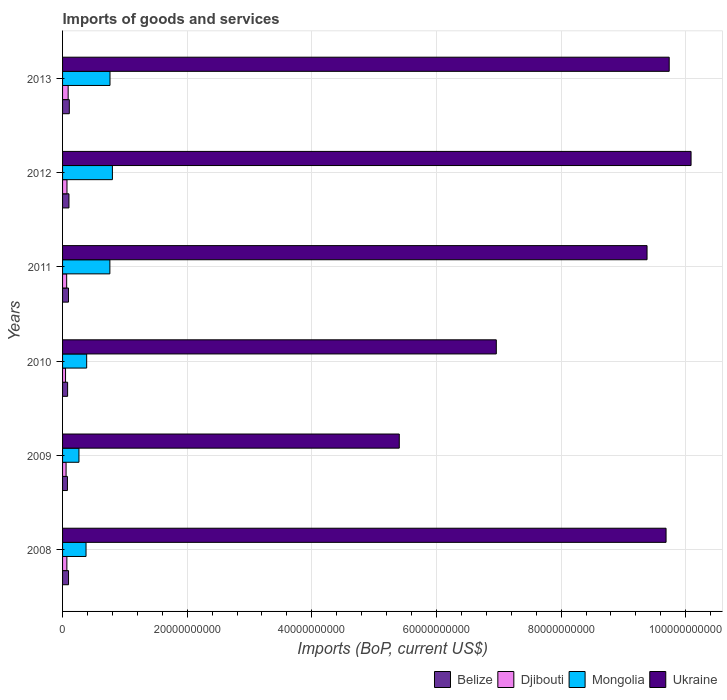How many different coloured bars are there?
Give a very brief answer. 4. Are the number of bars on each tick of the Y-axis equal?
Give a very brief answer. Yes. How many bars are there on the 1st tick from the bottom?
Your answer should be very brief. 4. What is the amount spent on imports in Mongolia in 2008?
Make the answer very short. 3.77e+09. Across all years, what is the maximum amount spent on imports in Ukraine?
Provide a succinct answer. 1.01e+11. Across all years, what is the minimum amount spent on imports in Ukraine?
Your response must be concise. 5.40e+1. What is the total amount spent on imports in Mongolia in the graph?
Keep it short and to the point. 3.35e+1. What is the difference between the amount spent on imports in Ukraine in 2011 and that in 2012?
Offer a very short reply. -7.06e+09. What is the difference between the amount spent on imports in Ukraine in 2011 and the amount spent on imports in Djibouti in 2012?
Offer a terse response. 9.31e+1. What is the average amount spent on imports in Ukraine per year?
Make the answer very short. 8.54e+1. In the year 2013, what is the difference between the amount spent on imports in Djibouti and amount spent on imports in Mongolia?
Give a very brief answer. -6.72e+09. In how many years, is the amount spent on imports in Ukraine greater than 16000000000 US$?
Provide a short and direct response. 6. What is the ratio of the amount spent on imports in Ukraine in 2012 to that in 2013?
Your answer should be compact. 1.04. Is the amount spent on imports in Belize in 2010 less than that in 2011?
Give a very brief answer. Yes. Is the difference between the amount spent on imports in Djibouti in 2008 and 2011 greater than the difference between the amount spent on imports in Mongolia in 2008 and 2011?
Your answer should be very brief. Yes. What is the difference between the highest and the second highest amount spent on imports in Mongolia?
Provide a succinct answer. 3.85e+08. What is the difference between the highest and the lowest amount spent on imports in Belize?
Provide a succinct answer. 3.01e+08. In how many years, is the amount spent on imports in Belize greater than the average amount spent on imports in Belize taken over all years?
Provide a succinct answer. 4. Is the sum of the amount spent on imports in Djibouti in 2009 and 2011 greater than the maximum amount spent on imports in Belize across all years?
Offer a very short reply. Yes. What does the 2nd bar from the top in 2013 represents?
Provide a succinct answer. Mongolia. What does the 2nd bar from the bottom in 2012 represents?
Your answer should be compact. Djibouti. How many bars are there?
Your answer should be very brief. 24. Are the values on the major ticks of X-axis written in scientific E-notation?
Your answer should be very brief. No. How many legend labels are there?
Your answer should be very brief. 4. How are the legend labels stacked?
Your answer should be very brief. Horizontal. What is the title of the graph?
Ensure brevity in your answer.  Imports of goods and services. Does "New Caledonia" appear as one of the legend labels in the graph?
Keep it short and to the point. No. What is the label or title of the X-axis?
Provide a short and direct response. Imports (BoP, current US$). What is the Imports (BoP, current US$) of Belize in 2008?
Ensure brevity in your answer.  9.58e+08. What is the Imports (BoP, current US$) of Djibouti in 2008?
Offer a terse response. 6.91e+08. What is the Imports (BoP, current US$) of Mongolia in 2008?
Make the answer very short. 3.77e+09. What is the Imports (BoP, current US$) in Ukraine in 2008?
Offer a terse response. 9.68e+1. What is the Imports (BoP, current US$) of Belize in 2009?
Your response must be concise. 7.82e+08. What is the Imports (BoP, current US$) in Djibouti in 2009?
Ensure brevity in your answer.  5.65e+08. What is the Imports (BoP, current US$) in Mongolia in 2009?
Your answer should be very brief. 2.63e+09. What is the Imports (BoP, current US$) in Ukraine in 2009?
Your answer should be compact. 5.40e+1. What is the Imports (BoP, current US$) of Belize in 2010?
Your answer should be compact. 8.10e+08. What is the Imports (BoP, current US$) in Djibouti in 2010?
Provide a succinct answer. 4.78e+08. What is the Imports (BoP, current US$) in Mongolia in 2010?
Keep it short and to the point. 3.87e+09. What is the Imports (BoP, current US$) in Ukraine in 2010?
Give a very brief answer. 6.96e+1. What is the Imports (BoP, current US$) in Belize in 2011?
Make the answer very short. 9.49e+08. What is the Imports (BoP, current US$) in Djibouti in 2011?
Provide a succinct answer. 6.58e+08. What is the Imports (BoP, current US$) of Mongolia in 2011?
Your answer should be very brief. 7.59e+09. What is the Imports (BoP, current US$) in Ukraine in 2011?
Your answer should be compact. 9.38e+1. What is the Imports (BoP, current US$) of Belize in 2012?
Provide a succinct answer. 1.03e+09. What is the Imports (BoP, current US$) of Djibouti in 2012?
Your answer should be compact. 7.09e+08. What is the Imports (BoP, current US$) in Mongolia in 2012?
Offer a very short reply. 8.00e+09. What is the Imports (BoP, current US$) of Ukraine in 2012?
Offer a terse response. 1.01e+11. What is the Imports (BoP, current US$) in Belize in 2013?
Your answer should be compact. 1.08e+09. What is the Imports (BoP, current US$) in Djibouti in 2013?
Provide a short and direct response. 8.98e+08. What is the Imports (BoP, current US$) in Mongolia in 2013?
Ensure brevity in your answer.  7.61e+09. What is the Imports (BoP, current US$) of Ukraine in 2013?
Offer a terse response. 9.74e+1. Across all years, what is the maximum Imports (BoP, current US$) in Belize?
Your answer should be compact. 1.08e+09. Across all years, what is the maximum Imports (BoP, current US$) in Djibouti?
Ensure brevity in your answer.  8.98e+08. Across all years, what is the maximum Imports (BoP, current US$) in Mongolia?
Offer a terse response. 8.00e+09. Across all years, what is the maximum Imports (BoP, current US$) of Ukraine?
Provide a succinct answer. 1.01e+11. Across all years, what is the minimum Imports (BoP, current US$) of Belize?
Provide a short and direct response. 7.82e+08. Across all years, what is the minimum Imports (BoP, current US$) in Djibouti?
Offer a very short reply. 4.78e+08. Across all years, what is the minimum Imports (BoP, current US$) in Mongolia?
Ensure brevity in your answer.  2.63e+09. Across all years, what is the minimum Imports (BoP, current US$) of Ukraine?
Give a very brief answer. 5.40e+1. What is the total Imports (BoP, current US$) in Belize in the graph?
Your answer should be compact. 5.61e+09. What is the total Imports (BoP, current US$) in Djibouti in the graph?
Provide a short and direct response. 4.00e+09. What is the total Imports (BoP, current US$) in Mongolia in the graph?
Ensure brevity in your answer.  3.35e+1. What is the total Imports (BoP, current US$) of Ukraine in the graph?
Offer a very short reply. 5.13e+11. What is the difference between the Imports (BoP, current US$) in Belize in 2008 and that in 2009?
Ensure brevity in your answer.  1.76e+08. What is the difference between the Imports (BoP, current US$) of Djibouti in 2008 and that in 2009?
Give a very brief answer. 1.26e+08. What is the difference between the Imports (BoP, current US$) in Mongolia in 2008 and that in 2009?
Provide a succinct answer. 1.14e+09. What is the difference between the Imports (BoP, current US$) in Ukraine in 2008 and that in 2009?
Offer a terse response. 4.28e+1. What is the difference between the Imports (BoP, current US$) of Belize in 2008 and that in 2010?
Keep it short and to the point. 1.48e+08. What is the difference between the Imports (BoP, current US$) of Djibouti in 2008 and that in 2010?
Offer a terse response. 2.12e+08. What is the difference between the Imports (BoP, current US$) of Mongolia in 2008 and that in 2010?
Offer a very short reply. -1.02e+08. What is the difference between the Imports (BoP, current US$) of Ukraine in 2008 and that in 2010?
Your answer should be compact. 2.72e+1. What is the difference between the Imports (BoP, current US$) of Belize in 2008 and that in 2011?
Keep it short and to the point. 8.56e+06. What is the difference between the Imports (BoP, current US$) in Djibouti in 2008 and that in 2011?
Your answer should be compact. 3.23e+07. What is the difference between the Imports (BoP, current US$) of Mongolia in 2008 and that in 2011?
Your answer should be compact. -3.82e+09. What is the difference between the Imports (BoP, current US$) in Ukraine in 2008 and that in 2011?
Your answer should be compact. 3.05e+09. What is the difference between the Imports (BoP, current US$) of Belize in 2008 and that in 2012?
Make the answer very short. -6.72e+07. What is the difference between the Imports (BoP, current US$) of Djibouti in 2008 and that in 2012?
Your answer should be compact. -1.84e+07. What is the difference between the Imports (BoP, current US$) of Mongolia in 2008 and that in 2012?
Your answer should be very brief. -4.23e+09. What is the difference between the Imports (BoP, current US$) in Ukraine in 2008 and that in 2012?
Your answer should be compact. -4.01e+09. What is the difference between the Imports (BoP, current US$) in Belize in 2008 and that in 2013?
Your answer should be compact. -1.26e+08. What is the difference between the Imports (BoP, current US$) of Djibouti in 2008 and that in 2013?
Give a very brief answer. -2.07e+08. What is the difference between the Imports (BoP, current US$) in Mongolia in 2008 and that in 2013?
Offer a very short reply. -3.85e+09. What is the difference between the Imports (BoP, current US$) in Ukraine in 2008 and that in 2013?
Offer a very short reply. -5.05e+08. What is the difference between the Imports (BoP, current US$) in Belize in 2009 and that in 2010?
Make the answer very short. -2.74e+07. What is the difference between the Imports (BoP, current US$) of Djibouti in 2009 and that in 2010?
Offer a very short reply. 8.62e+07. What is the difference between the Imports (BoP, current US$) of Mongolia in 2009 and that in 2010?
Keep it short and to the point. -1.24e+09. What is the difference between the Imports (BoP, current US$) of Ukraine in 2009 and that in 2010?
Keep it short and to the point. -1.56e+1. What is the difference between the Imports (BoP, current US$) of Belize in 2009 and that in 2011?
Ensure brevity in your answer.  -1.67e+08. What is the difference between the Imports (BoP, current US$) in Djibouti in 2009 and that in 2011?
Give a very brief answer. -9.37e+07. What is the difference between the Imports (BoP, current US$) in Mongolia in 2009 and that in 2011?
Offer a very short reply. -4.96e+09. What is the difference between the Imports (BoP, current US$) of Ukraine in 2009 and that in 2011?
Make the answer very short. -3.98e+1. What is the difference between the Imports (BoP, current US$) of Belize in 2009 and that in 2012?
Provide a succinct answer. -2.43e+08. What is the difference between the Imports (BoP, current US$) of Djibouti in 2009 and that in 2012?
Your response must be concise. -1.44e+08. What is the difference between the Imports (BoP, current US$) in Mongolia in 2009 and that in 2012?
Offer a very short reply. -5.37e+09. What is the difference between the Imports (BoP, current US$) of Ukraine in 2009 and that in 2012?
Ensure brevity in your answer.  -4.68e+1. What is the difference between the Imports (BoP, current US$) in Belize in 2009 and that in 2013?
Keep it short and to the point. -3.01e+08. What is the difference between the Imports (BoP, current US$) of Djibouti in 2009 and that in 2013?
Offer a very short reply. -3.33e+08. What is the difference between the Imports (BoP, current US$) of Mongolia in 2009 and that in 2013?
Offer a terse response. -4.98e+09. What is the difference between the Imports (BoP, current US$) of Ukraine in 2009 and that in 2013?
Keep it short and to the point. -4.33e+1. What is the difference between the Imports (BoP, current US$) in Belize in 2010 and that in 2011?
Make the answer very short. -1.40e+08. What is the difference between the Imports (BoP, current US$) of Djibouti in 2010 and that in 2011?
Provide a succinct answer. -1.80e+08. What is the difference between the Imports (BoP, current US$) in Mongolia in 2010 and that in 2011?
Your answer should be compact. -3.72e+09. What is the difference between the Imports (BoP, current US$) in Ukraine in 2010 and that in 2011?
Your answer should be very brief. -2.42e+1. What is the difference between the Imports (BoP, current US$) in Belize in 2010 and that in 2012?
Keep it short and to the point. -2.15e+08. What is the difference between the Imports (BoP, current US$) of Djibouti in 2010 and that in 2012?
Your response must be concise. -2.31e+08. What is the difference between the Imports (BoP, current US$) in Mongolia in 2010 and that in 2012?
Make the answer very short. -4.13e+09. What is the difference between the Imports (BoP, current US$) in Ukraine in 2010 and that in 2012?
Offer a terse response. -3.13e+1. What is the difference between the Imports (BoP, current US$) in Belize in 2010 and that in 2013?
Ensure brevity in your answer.  -2.74e+08. What is the difference between the Imports (BoP, current US$) in Djibouti in 2010 and that in 2013?
Offer a terse response. -4.19e+08. What is the difference between the Imports (BoP, current US$) of Mongolia in 2010 and that in 2013?
Give a very brief answer. -3.74e+09. What is the difference between the Imports (BoP, current US$) of Ukraine in 2010 and that in 2013?
Your answer should be compact. -2.77e+1. What is the difference between the Imports (BoP, current US$) in Belize in 2011 and that in 2012?
Your response must be concise. -7.58e+07. What is the difference between the Imports (BoP, current US$) in Djibouti in 2011 and that in 2012?
Ensure brevity in your answer.  -5.07e+07. What is the difference between the Imports (BoP, current US$) in Mongolia in 2011 and that in 2012?
Give a very brief answer. -4.07e+08. What is the difference between the Imports (BoP, current US$) of Ukraine in 2011 and that in 2012?
Provide a short and direct response. -7.06e+09. What is the difference between the Imports (BoP, current US$) in Belize in 2011 and that in 2013?
Your answer should be very brief. -1.34e+08. What is the difference between the Imports (BoP, current US$) of Djibouti in 2011 and that in 2013?
Provide a short and direct response. -2.39e+08. What is the difference between the Imports (BoP, current US$) in Mongolia in 2011 and that in 2013?
Your answer should be very brief. -2.18e+07. What is the difference between the Imports (BoP, current US$) of Ukraine in 2011 and that in 2013?
Your answer should be compact. -3.56e+09. What is the difference between the Imports (BoP, current US$) of Belize in 2012 and that in 2013?
Keep it short and to the point. -5.86e+07. What is the difference between the Imports (BoP, current US$) in Djibouti in 2012 and that in 2013?
Offer a terse response. -1.88e+08. What is the difference between the Imports (BoP, current US$) of Mongolia in 2012 and that in 2013?
Keep it short and to the point. 3.85e+08. What is the difference between the Imports (BoP, current US$) of Ukraine in 2012 and that in 2013?
Offer a terse response. 3.51e+09. What is the difference between the Imports (BoP, current US$) in Belize in 2008 and the Imports (BoP, current US$) in Djibouti in 2009?
Your response must be concise. 3.93e+08. What is the difference between the Imports (BoP, current US$) of Belize in 2008 and the Imports (BoP, current US$) of Mongolia in 2009?
Offer a terse response. -1.67e+09. What is the difference between the Imports (BoP, current US$) of Belize in 2008 and the Imports (BoP, current US$) of Ukraine in 2009?
Your response must be concise. -5.31e+1. What is the difference between the Imports (BoP, current US$) of Djibouti in 2008 and the Imports (BoP, current US$) of Mongolia in 2009?
Provide a succinct answer. -1.94e+09. What is the difference between the Imports (BoP, current US$) of Djibouti in 2008 and the Imports (BoP, current US$) of Ukraine in 2009?
Your answer should be very brief. -5.33e+1. What is the difference between the Imports (BoP, current US$) of Mongolia in 2008 and the Imports (BoP, current US$) of Ukraine in 2009?
Your answer should be very brief. -5.03e+1. What is the difference between the Imports (BoP, current US$) of Belize in 2008 and the Imports (BoP, current US$) of Djibouti in 2010?
Offer a terse response. 4.79e+08. What is the difference between the Imports (BoP, current US$) of Belize in 2008 and the Imports (BoP, current US$) of Mongolia in 2010?
Your response must be concise. -2.91e+09. What is the difference between the Imports (BoP, current US$) of Belize in 2008 and the Imports (BoP, current US$) of Ukraine in 2010?
Ensure brevity in your answer.  -6.87e+1. What is the difference between the Imports (BoP, current US$) of Djibouti in 2008 and the Imports (BoP, current US$) of Mongolia in 2010?
Provide a succinct answer. -3.18e+09. What is the difference between the Imports (BoP, current US$) of Djibouti in 2008 and the Imports (BoP, current US$) of Ukraine in 2010?
Offer a terse response. -6.89e+1. What is the difference between the Imports (BoP, current US$) of Mongolia in 2008 and the Imports (BoP, current US$) of Ukraine in 2010?
Make the answer very short. -6.58e+1. What is the difference between the Imports (BoP, current US$) of Belize in 2008 and the Imports (BoP, current US$) of Djibouti in 2011?
Provide a succinct answer. 2.99e+08. What is the difference between the Imports (BoP, current US$) in Belize in 2008 and the Imports (BoP, current US$) in Mongolia in 2011?
Give a very brief answer. -6.63e+09. What is the difference between the Imports (BoP, current US$) in Belize in 2008 and the Imports (BoP, current US$) in Ukraine in 2011?
Offer a very short reply. -9.28e+1. What is the difference between the Imports (BoP, current US$) of Djibouti in 2008 and the Imports (BoP, current US$) of Mongolia in 2011?
Give a very brief answer. -6.90e+09. What is the difference between the Imports (BoP, current US$) of Djibouti in 2008 and the Imports (BoP, current US$) of Ukraine in 2011?
Give a very brief answer. -9.31e+1. What is the difference between the Imports (BoP, current US$) of Mongolia in 2008 and the Imports (BoP, current US$) of Ukraine in 2011?
Provide a short and direct response. -9.00e+1. What is the difference between the Imports (BoP, current US$) of Belize in 2008 and the Imports (BoP, current US$) of Djibouti in 2012?
Make the answer very short. 2.49e+08. What is the difference between the Imports (BoP, current US$) in Belize in 2008 and the Imports (BoP, current US$) in Mongolia in 2012?
Your response must be concise. -7.04e+09. What is the difference between the Imports (BoP, current US$) of Belize in 2008 and the Imports (BoP, current US$) of Ukraine in 2012?
Your answer should be very brief. -9.99e+1. What is the difference between the Imports (BoP, current US$) in Djibouti in 2008 and the Imports (BoP, current US$) in Mongolia in 2012?
Your answer should be compact. -7.31e+09. What is the difference between the Imports (BoP, current US$) in Djibouti in 2008 and the Imports (BoP, current US$) in Ukraine in 2012?
Ensure brevity in your answer.  -1.00e+11. What is the difference between the Imports (BoP, current US$) of Mongolia in 2008 and the Imports (BoP, current US$) of Ukraine in 2012?
Offer a very short reply. -9.71e+1. What is the difference between the Imports (BoP, current US$) of Belize in 2008 and the Imports (BoP, current US$) of Djibouti in 2013?
Your answer should be very brief. 6.03e+07. What is the difference between the Imports (BoP, current US$) of Belize in 2008 and the Imports (BoP, current US$) of Mongolia in 2013?
Offer a very short reply. -6.66e+09. What is the difference between the Imports (BoP, current US$) in Belize in 2008 and the Imports (BoP, current US$) in Ukraine in 2013?
Your answer should be very brief. -9.64e+1. What is the difference between the Imports (BoP, current US$) of Djibouti in 2008 and the Imports (BoP, current US$) of Mongolia in 2013?
Make the answer very short. -6.92e+09. What is the difference between the Imports (BoP, current US$) of Djibouti in 2008 and the Imports (BoP, current US$) of Ukraine in 2013?
Offer a very short reply. -9.67e+1. What is the difference between the Imports (BoP, current US$) in Mongolia in 2008 and the Imports (BoP, current US$) in Ukraine in 2013?
Provide a succinct answer. -9.36e+1. What is the difference between the Imports (BoP, current US$) in Belize in 2009 and the Imports (BoP, current US$) in Djibouti in 2010?
Offer a very short reply. 3.04e+08. What is the difference between the Imports (BoP, current US$) of Belize in 2009 and the Imports (BoP, current US$) of Mongolia in 2010?
Make the answer very short. -3.09e+09. What is the difference between the Imports (BoP, current US$) in Belize in 2009 and the Imports (BoP, current US$) in Ukraine in 2010?
Your response must be concise. -6.88e+1. What is the difference between the Imports (BoP, current US$) of Djibouti in 2009 and the Imports (BoP, current US$) of Mongolia in 2010?
Offer a very short reply. -3.30e+09. What is the difference between the Imports (BoP, current US$) in Djibouti in 2009 and the Imports (BoP, current US$) in Ukraine in 2010?
Your answer should be very brief. -6.90e+1. What is the difference between the Imports (BoP, current US$) of Mongolia in 2009 and the Imports (BoP, current US$) of Ukraine in 2010?
Offer a very short reply. -6.70e+1. What is the difference between the Imports (BoP, current US$) in Belize in 2009 and the Imports (BoP, current US$) in Djibouti in 2011?
Give a very brief answer. 1.24e+08. What is the difference between the Imports (BoP, current US$) of Belize in 2009 and the Imports (BoP, current US$) of Mongolia in 2011?
Ensure brevity in your answer.  -6.81e+09. What is the difference between the Imports (BoP, current US$) in Belize in 2009 and the Imports (BoP, current US$) in Ukraine in 2011?
Your answer should be compact. -9.30e+1. What is the difference between the Imports (BoP, current US$) in Djibouti in 2009 and the Imports (BoP, current US$) in Mongolia in 2011?
Keep it short and to the point. -7.03e+09. What is the difference between the Imports (BoP, current US$) in Djibouti in 2009 and the Imports (BoP, current US$) in Ukraine in 2011?
Make the answer very short. -9.32e+1. What is the difference between the Imports (BoP, current US$) of Mongolia in 2009 and the Imports (BoP, current US$) of Ukraine in 2011?
Ensure brevity in your answer.  -9.12e+1. What is the difference between the Imports (BoP, current US$) in Belize in 2009 and the Imports (BoP, current US$) in Djibouti in 2012?
Offer a terse response. 7.32e+07. What is the difference between the Imports (BoP, current US$) of Belize in 2009 and the Imports (BoP, current US$) of Mongolia in 2012?
Your response must be concise. -7.22e+09. What is the difference between the Imports (BoP, current US$) of Belize in 2009 and the Imports (BoP, current US$) of Ukraine in 2012?
Keep it short and to the point. -1.00e+11. What is the difference between the Imports (BoP, current US$) in Djibouti in 2009 and the Imports (BoP, current US$) in Mongolia in 2012?
Your answer should be compact. -7.43e+09. What is the difference between the Imports (BoP, current US$) in Djibouti in 2009 and the Imports (BoP, current US$) in Ukraine in 2012?
Offer a terse response. -1.00e+11. What is the difference between the Imports (BoP, current US$) of Mongolia in 2009 and the Imports (BoP, current US$) of Ukraine in 2012?
Offer a very short reply. -9.82e+1. What is the difference between the Imports (BoP, current US$) in Belize in 2009 and the Imports (BoP, current US$) in Djibouti in 2013?
Your answer should be very brief. -1.15e+08. What is the difference between the Imports (BoP, current US$) of Belize in 2009 and the Imports (BoP, current US$) of Mongolia in 2013?
Offer a very short reply. -6.83e+09. What is the difference between the Imports (BoP, current US$) in Belize in 2009 and the Imports (BoP, current US$) in Ukraine in 2013?
Ensure brevity in your answer.  -9.66e+1. What is the difference between the Imports (BoP, current US$) in Djibouti in 2009 and the Imports (BoP, current US$) in Mongolia in 2013?
Give a very brief answer. -7.05e+09. What is the difference between the Imports (BoP, current US$) of Djibouti in 2009 and the Imports (BoP, current US$) of Ukraine in 2013?
Offer a terse response. -9.68e+1. What is the difference between the Imports (BoP, current US$) in Mongolia in 2009 and the Imports (BoP, current US$) in Ukraine in 2013?
Offer a terse response. -9.47e+1. What is the difference between the Imports (BoP, current US$) of Belize in 2010 and the Imports (BoP, current US$) of Djibouti in 2011?
Your answer should be compact. 1.51e+08. What is the difference between the Imports (BoP, current US$) in Belize in 2010 and the Imports (BoP, current US$) in Mongolia in 2011?
Make the answer very short. -6.78e+09. What is the difference between the Imports (BoP, current US$) of Belize in 2010 and the Imports (BoP, current US$) of Ukraine in 2011?
Your response must be concise. -9.30e+1. What is the difference between the Imports (BoP, current US$) of Djibouti in 2010 and the Imports (BoP, current US$) of Mongolia in 2011?
Provide a succinct answer. -7.11e+09. What is the difference between the Imports (BoP, current US$) in Djibouti in 2010 and the Imports (BoP, current US$) in Ukraine in 2011?
Keep it short and to the point. -9.33e+1. What is the difference between the Imports (BoP, current US$) in Mongolia in 2010 and the Imports (BoP, current US$) in Ukraine in 2011?
Offer a terse response. -8.99e+1. What is the difference between the Imports (BoP, current US$) of Belize in 2010 and the Imports (BoP, current US$) of Djibouti in 2012?
Make the answer very short. 1.01e+08. What is the difference between the Imports (BoP, current US$) in Belize in 2010 and the Imports (BoP, current US$) in Mongolia in 2012?
Your answer should be very brief. -7.19e+09. What is the difference between the Imports (BoP, current US$) in Belize in 2010 and the Imports (BoP, current US$) in Ukraine in 2012?
Offer a very short reply. -1.00e+11. What is the difference between the Imports (BoP, current US$) of Djibouti in 2010 and the Imports (BoP, current US$) of Mongolia in 2012?
Provide a short and direct response. -7.52e+09. What is the difference between the Imports (BoP, current US$) in Djibouti in 2010 and the Imports (BoP, current US$) in Ukraine in 2012?
Your response must be concise. -1.00e+11. What is the difference between the Imports (BoP, current US$) in Mongolia in 2010 and the Imports (BoP, current US$) in Ukraine in 2012?
Make the answer very short. -9.70e+1. What is the difference between the Imports (BoP, current US$) of Belize in 2010 and the Imports (BoP, current US$) of Djibouti in 2013?
Make the answer very short. -8.79e+07. What is the difference between the Imports (BoP, current US$) of Belize in 2010 and the Imports (BoP, current US$) of Mongolia in 2013?
Ensure brevity in your answer.  -6.80e+09. What is the difference between the Imports (BoP, current US$) of Belize in 2010 and the Imports (BoP, current US$) of Ukraine in 2013?
Keep it short and to the point. -9.65e+1. What is the difference between the Imports (BoP, current US$) in Djibouti in 2010 and the Imports (BoP, current US$) in Mongolia in 2013?
Provide a short and direct response. -7.13e+09. What is the difference between the Imports (BoP, current US$) of Djibouti in 2010 and the Imports (BoP, current US$) of Ukraine in 2013?
Your answer should be compact. -9.69e+1. What is the difference between the Imports (BoP, current US$) of Mongolia in 2010 and the Imports (BoP, current US$) of Ukraine in 2013?
Keep it short and to the point. -9.35e+1. What is the difference between the Imports (BoP, current US$) in Belize in 2011 and the Imports (BoP, current US$) in Djibouti in 2012?
Keep it short and to the point. 2.40e+08. What is the difference between the Imports (BoP, current US$) of Belize in 2011 and the Imports (BoP, current US$) of Mongolia in 2012?
Ensure brevity in your answer.  -7.05e+09. What is the difference between the Imports (BoP, current US$) of Belize in 2011 and the Imports (BoP, current US$) of Ukraine in 2012?
Give a very brief answer. -9.99e+1. What is the difference between the Imports (BoP, current US$) in Djibouti in 2011 and the Imports (BoP, current US$) in Mongolia in 2012?
Offer a terse response. -7.34e+09. What is the difference between the Imports (BoP, current US$) of Djibouti in 2011 and the Imports (BoP, current US$) of Ukraine in 2012?
Offer a terse response. -1.00e+11. What is the difference between the Imports (BoP, current US$) in Mongolia in 2011 and the Imports (BoP, current US$) in Ukraine in 2012?
Your answer should be very brief. -9.33e+1. What is the difference between the Imports (BoP, current US$) of Belize in 2011 and the Imports (BoP, current US$) of Djibouti in 2013?
Your response must be concise. 5.17e+07. What is the difference between the Imports (BoP, current US$) of Belize in 2011 and the Imports (BoP, current US$) of Mongolia in 2013?
Offer a very short reply. -6.66e+09. What is the difference between the Imports (BoP, current US$) in Belize in 2011 and the Imports (BoP, current US$) in Ukraine in 2013?
Make the answer very short. -9.64e+1. What is the difference between the Imports (BoP, current US$) in Djibouti in 2011 and the Imports (BoP, current US$) in Mongolia in 2013?
Your answer should be compact. -6.95e+09. What is the difference between the Imports (BoP, current US$) of Djibouti in 2011 and the Imports (BoP, current US$) of Ukraine in 2013?
Keep it short and to the point. -9.67e+1. What is the difference between the Imports (BoP, current US$) in Mongolia in 2011 and the Imports (BoP, current US$) in Ukraine in 2013?
Give a very brief answer. -8.98e+1. What is the difference between the Imports (BoP, current US$) of Belize in 2012 and the Imports (BoP, current US$) of Djibouti in 2013?
Offer a very short reply. 1.28e+08. What is the difference between the Imports (BoP, current US$) of Belize in 2012 and the Imports (BoP, current US$) of Mongolia in 2013?
Your answer should be very brief. -6.59e+09. What is the difference between the Imports (BoP, current US$) in Belize in 2012 and the Imports (BoP, current US$) in Ukraine in 2013?
Your response must be concise. -9.63e+1. What is the difference between the Imports (BoP, current US$) in Djibouti in 2012 and the Imports (BoP, current US$) in Mongolia in 2013?
Offer a terse response. -6.90e+09. What is the difference between the Imports (BoP, current US$) in Djibouti in 2012 and the Imports (BoP, current US$) in Ukraine in 2013?
Offer a very short reply. -9.66e+1. What is the difference between the Imports (BoP, current US$) in Mongolia in 2012 and the Imports (BoP, current US$) in Ukraine in 2013?
Your answer should be very brief. -8.94e+1. What is the average Imports (BoP, current US$) of Belize per year?
Offer a very short reply. 9.35e+08. What is the average Imports (BoP, current US$) in Djibouti per year?
Your answer should be compact. 6.66e+08. What is the average Imports (BoP, current US$) of Mongolia per year?
Offer a very short reply. 5.58e+09. What is the average Imports (BoP, current US$) of Ukraine per year?
Ensure brevity in your answer.  8.54e+1. In the year 2008, what is the difference between the Imports (BoP, current US$) in Belize and Imports (BoP, current US$) in Djibouti?
Provide a short and direct response. 2.67e+08. In the year 2008, what is the difference between the Imports (BoP, current US$) of Belize and Imports (BoP, current US$) of Mongolia?
Give a very brief answer. -2.81e+09. In the year 2008, what is the difference between the Imports (BoP, current US$) of Belize and Imports (BoP, current US$) of Ukraine?
Your answer should be very brief. -9.59e+1. In the year 2008, what is the difference between the Imports (BoP, current US$) of Djibouti and Imports (BoP, current US$) of Mongolia?
Keep it short and to the point. -3.08e+09. In the year 2008, what is the difference between the Imports (BoP, current US$) in Djibouti and Imports (BoP, current US$) in Ukraine?
Your response must be concise. -9.62e+1. In the year 2008, what is the difference between the Imports (BoP, current US$) in Mongolia and Imports (BoP, current US$) in Ukraine?
Offer a very short reply. -9.31e+1. In the year 2009, what is the difference between the Imports (BoP, current US$) of Belize and Imports (BoP, current US$) of Djibouti?
Your answer should be compact. 2.18e+08. In the year 2009, what is the difference between the Imports (BoP, current US$) of Belize and Imports (BoP, current US$) of Mongolia?
Offer a terse response. -1.85e+09. In the year 2009, what is the difference between the Imports (BoP, current US$) of Belize and Imports (BoP, current US$) of Ukraine?
Ensure brevity in your answer.  -5.33e+1. In the year 2009, what is the difference between the Imports (BoP, current US$) in Djibouti and Imports (BoP, current US$) in Mongolia?
Ensure brevity in your answer.  -2.07e+09. In the year 2009, what is the difference between the Imports (BoP, current US$) in Djibouti and Imports (BoP, current US$) in Ukraine?
Your answer should be compact. -5.35e+1. In the year 2009, what is the difference between the Imports (BoP, current US$) in Mongolia and Imports (BoP, current US$) in Ukraine?
Provide a short and direct response. -5.14e+1. In the year 2010, what is the difference between the Imports (BoP, current US$) in Belize and Imports (BoP, current US$) in Djibouti?
Give a very brief answer. 3.31e+08. In the year 2010, what is the difference between the Imports (BoP, current US$) of Belize and Imports (BoP, current US$) of Mongolia?
Offer a very short reply. -3.06e+09. In the year 2010, what is the difference between the Imports (BoP, current US$) in Belize and Imports (BoP, current US$) in Ukraine?
Your answer should be compact. -6.88e+1. In the year 2010, what is the difference between the Imports (BoP, current US$) of Djibouti and Imports (BoP, current US$) of Mongolia?
Provide a short and direct response. -3.39e+09. In the year 2010, what is the difference between the Imports (BoP, current US$) in Djibouti and Imports (BoP, current US$) in Ukraine?
Your response must be concise. -6.91e+1. In the year 2010, what is the difference between the Imports (BoP, current US$) in Mongolia and Imports (BoP, current US$) in Ukraine?
Keep it short and to the point. -6.57e+1. In the year 2011, what is the difference between the Imports (BoP, current US$) in Belize and Imports (BoP, current US$) in Djibouti?
Your answer should be very brief. 2.91e+08. In the year 2011, what is the difference between the Imports (BoP, current US$) in Belize and Imports (BoP, current US$) in Mongolia?
Your answer should be very brief. -6.64e+09. In the year 2011, what is the difference between the Imports (BoP, current US$) in Belize and Imports (BoP, current US$) in Ukraine?
Make the answer very short. -9.28e+1. In the year 2011, what is the difference between the Imports (BoP, current US$) in Djibouti and Imports (BoP, current US$) in Mongolia?
Make the answer very short. -6.93e+09. In the year 2011, what is the difference between the Imports (BoP, current US$) of Djibouti and Imports (BoP, current US$) of Ukraine?
Give a very brief answer. -9.31e+1. In the year 2011, what is the difference between the Imports (BoP, current US$) of Mongolia and Imports (BoP, current US$) of Ukraine?
Offer a very short reply. -8.62e+1. In the year 2012, what is the difference between the Imports (BoP, current US$) in Belize and Imports (BoP, current US$) in Djibouti?
Your response must be concise. 3.16e+08. In the year 2012, what is the difference between the Imports (BoP, current US$) of Belize and Imports (BoP, current US$) of Mongolia?
Your answer should be very brief. -6.97e+09. In the year 2012, what is the difference between the Imports (BoP, current US$) of Belize and Imports (BoP, current US$) of Ukraine?
Keep it short and to the point. -9.98e+1. In the year 2012, what is the difference between the Imports (BoP, current US$) of Djibouti and Imports (BoP, current US$) of Mongolia?
Ensure brevity in your answer.  -7.29e+09. In the year 2012, what is the difference between the Imports (BoP, current US$) of Djibouti and Imports (BoP, current US$) of Ukraine?
Make the answer very short. -1.00e+11. In the year 2012, what is the difference between the Imports (BoP, current US$) of Mongolia and Imports (BoP, current US$) of Ukraine?
Ensure brevity in your answer.  -9.29e+1. In the year 2013, what is the difference between the Imports (BoP, current US$) in Belize and Imports (BoP, current US$) in Djibouti?
Give a very brief answer. 1.86e+08. In the year 2013, what is the difference between the Imports (BoP, current US$) in Belize and Imports (BoP, current US$) in Mongolia?
Offer a terse response. -6.53e+09. In the year 2013, what is the difference between the Imports (BoP, current US$) of Belize and Imports (BoP, current US$) of Ukraine?
Provide a succinct answer. -9.63e+1. In the year 2013, what is the difference between the Imports (BoP, current US$) of Djibouti and Imports (BoP, current US$) of Mongolia?
Offer a very short reply. -6.72e+09. In the year 2013, what is the difference between the Imports (BoP, current US$) of Djibouti and Imports (BoP, current US$) of Ukraine?
Offer a very short reply. -9.65e+1. In the year 2013, what is the difference between the Imports (BoP, current US$) in Mongolia and Imports (BoP, current US$) in Ukraine?
Ensure brevity in your answer.  -8.97e+1. What is the ratio of the Imports (BoP, current US$) of Belize in 2008 to that in 2009?
Provide a succinct answer. 1.22. What is the ratio of the Imports (BoP, current US$) of Djibouti in 2008 to that in 2009?
Offer a terse response. 1.22. What is the ratio of the Imports (BoP, current US$) of Mongolia in 2008 to that in 2009?
Keep it short and to the point. 1.43. What is the ratio of the Imports (BoP, current US$) in Ukraine in 2008 to that in 2009?
Provide a short and direct response. 1.79. What is the ratio of the Imports (BoP, current US$) of Belize in 2008 to that in 2010?
Offer a very short reply. 1.18. What is the ratio of the Imports (BoP, current US$) of Djibouti in 2008 to that in 2010?
Your response must be concise. 1.44. What is the ratio of the Imports (BoP, current US$) in Mongolia in 2008 to that in 2010?
Make the answer very short. 0.97. What is the ratio of the Imports (BoP, current US$) in Ukraine in 2008 to that in 2010?
Your answer should be compact. 1.39. What is the ratio of the Imports (BoP, current US$) in Djibouti in 2008 to that in 2011?
Your answer should be compact. 1.05. What is the ratio of the Imports (BoP, current US$) of Mongolia in 2008 to that in 2011?
Make the answer very short. 0.5. What is the ratio of the Imports (BoP, current US$) of Ukraine in 2008 to that in 2011?
Make the answer very short. 1.03. What is the ratio of the Imports (BoP, current US$) of Belize in 2008 to that in 2012?
Offer a very short reply. 0.93. What is the ratio of the Imports (BoP, current US$) in Djibouti in 2008 to that in 2012?
Offer a very short reply. 0.97. What is the ratio of the Imports (BoP, current US$) in Mongolia in 2008 to that in 2012?
Provide a short and direct response. 0.47. What is the ratio of the Imports (BoP, current US$) in Ukraine in 2008 to that in 2012?
Make the answer very short. 0.96. What is the ratio of the Imports (BoP, current US$) in Belize in 2008 to that in 2013?
Your answer should be very brief. 0.88. What is the ratio of the Imports (BoP, current US$) of Djibouti in 2008 to that in 2013?
Provide a succinct answer. 0.77. What is the ratio of the Imports (BoP, current US$) of Mongolia in 2008 to that in 2013?
Provide a short and direct response. 0.49. What is the ratio of the Imports (BoP, current US$) in Ukraine in 2008 to that in 2013?
Your answer should be very brief. 0.99. What is the ratio of the Imports (BoP, current US$) of Belize in 2009 to that in 2010?
Make the answer very short. 0.97. What is the ratio of the Imports (BoP, current US$) of Djibouti in 2009 to that in 2010?
Ensure brevity in your answer.  1.18. What is the ratio of the Imports (BoP, current US$) in Mongolia in 2009 to that in 2010?
Give a very brief answer. 0.68. What is the ratio of the Imports (BoP, current US$) of Ukraine in 2009 to that in 2010?
Provide a succinct answer. 0.78. What is the ratio of the Imports (BoP, current US$) in Belize in 2009 to that in 2011?
Your answer should be compact. 0.82. What is the ratio of the Imports (BoP, current US$) in Djibouti in 2009 to that in 2011?
Offer a terse response. 0.86. What is the ratio of the Imports (BoP, current US$) in Mongolia in 2009 to that in 2011?
Provide a succinct answer. 0.35. What is the ratio of the Imports (BoP, current US$) of Ukraine in 2009 to that in 2011?
Provide a short and direct response. 0.58. What is the ratio of the Imports (BoP, current US$) in Belize in 2009 to that in 2012?
Give a very brief answer. 0.76. What is the ratio of the Imports (BoP, current US$) in Djibouti in 2009 to that in 2012?
Keep it short and to the point. 0.8. What is the ratio of the Imports (BoP, current US$) in Mongolia in 2009 to that in 2012?
Keep it short and to the point. 0.33. What is the ratio of the Imports (BoP, current US$) of Ukraine in 2009 to that in 2012?
Your answer should be very brief. 0.54. What is the ratio of the Imports (BoP, current US$) of Belize in 2009 to that in 2013?
Give a very brief answer. 0.72. What is the ratio of the Imports (BoP, current US$) in Djibouti in 2009 to that in 2013?
Keep it short and to the point. 0.63. What is the ratio of the Imports (BoP, current US$) in Mongolia in 2009 to that in 2013?
Provide a succinct answer. 0.35. What is the ratio of the Imports (BoP, current US$) in Ukraine in 2009 to that in 2013?
Make the answer very short. 0.56. What is the ratio of the Imports (BoP, current US$) of Belize in 2010 to that in 2011?
Offer a very short reply. 0.85. What is the ratio of the Imports (BoP, current US$) of Djibouti in 2010 to that in 2011?
Make the answer very short. 0.73. What is the ratio of the Imports (BoP, current US$) of Mongolia in 2010 to that in 2011?
Offer a very short reply. 0.51. What is the ratio of the Imports (BoP, current US$) of Ukraine in 2010 to that in 2011?
Offer a very short reply. 0.74. What is the ratio of the Imports (BoP, current US$) in Belize in 2010 to that in 2012?
Ensure brevity in your answer.  0.79. What is the ratio of the Imports (BoP, current US$) in Djibouti in 2010 to that in 2012?
Ensure brevity in your answer.  0.67. What is the ratio of the Imports (BoP, current US$) of Mongolia in 2010 to that in 2012?
Your response must be concise. 0.48. What is the ratio of the Imports (BoP, current US$) of Ukraine in 2010 to that in 2012?
Your answer should be very brief. 0.69. What is the ratio of the Imports (BoP, current US$) of Belize in 2010 to that in 2013?
Provide a short and direct response. 0.75. What is the ratio of the Imports (BoP, current US$) of Djibouti in 2010 to that in 2013?
Ensure brevity in your answer.  0.53. What is the ratio of the Imports (BoP, current US$) of Mongolia in 2010 to that in 2013?
Make the answer very short. 0.51. What is the ratio of the Imports (BoP, current US$) in Ukraine in 2010 to that in 2013?
Your response must be concise. 0.71. What is the ratio of the Imports (BoP, current US$) in Belize in 2011 to that in 2012?
Make the answer very short. 0.93. What is the ratio of the Imports (BoP, current US$) of Djibouti in 2011 to that in 2012?
Provide a succinct answer. 0.93. What is the ratio of the Imports (BoP, current US$) in Mongolia in 2011 to that in 2012?
Provide a succinct answer. 0.95. What is the ratio of the Imports (BoP, current US$) in Belize in 2011 to that in 2013?
Offer a very short reply. 0.88. What is the ratio of the Imports (BoP, current US$) in Djibouti in 2011 to that in 2013?
Provide a succinct answer. 0.73. What is the ratio of the Imports (BoP, current US$) in Mongolia in 2011 to that in 2013?
Offer a very short reply. 1. What is the ratio of the Imports (BoP, current US$) in Ukraine in 2011 to that in 2013?
Your response must be concise. 0.96. What is the ratio of the Imports (BoP, current US$) of Belize in 2012 to that in 2013?
Your response must be concise. 0.95. What is the ratio of the Imports (BoP, current US$) of Djibouti in 2012 to that in 2013?
Offer a terse response. 0.79. What is the ratio of the Imports (BoP, current US$) of Mongolia in 2012 to that in 2013?
Your answer should be very brief. 1.05. What is the ratio of the Imports (BoP, current US$) in Ukraine in 2012 to that in 2013?
Give a very brief answer. 1.04. What is the difference between the highest and the second highest Imports (BoP, current US$) of Belize?
Provide a succinct answer. 5.86e+07. What is the difference between the highest and the second highest Imports (BoP, current US$) in Djibouti?
Your answer should be compact. 1.88e+08. What is the difference between the highest and the second highest Imports (BoP, current US$) of Mongolia?
Give a very brief answer. 3.85e+08. What is the difference between the highest and the second highest Imports (BoP, current US$) in Ukraine?
Give a very brief answer. 3.51e+09. What is the difference between the highest and the lowest Imports (BoP, current US$) of Belize?
Your answer should be compact. 3.01e+08. What is the difference between the highest and the lowest Imports (BoP, current US$) in Djibouti?
Your answer should be very brief. 4.19e+08. What is the difference between the highest and the lowest Imports (BoP, current US$) in Mongolia?
Make the answer very short. 5.37e+09. What is the difference between the highest and the lowest Imports (BoP, current US$) of Ukraine?
Give a very brief answer. 4.68e+1. 